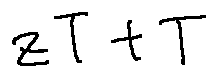<formula> <loc_0><loc_0><loc_500><loc_500>z T + T</formula> 